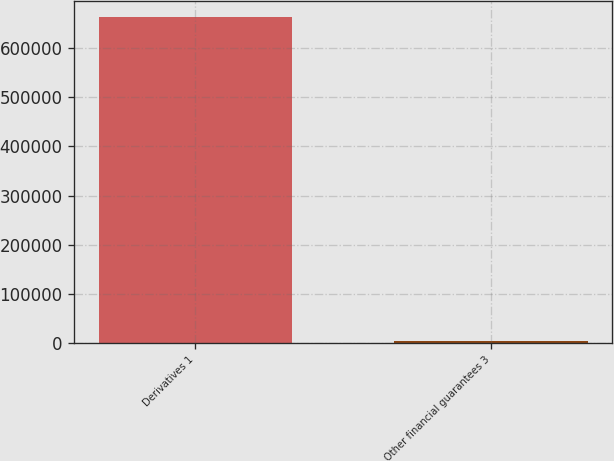Convert chart. <chart><loc_0><loc_0><loc_500><loc_500><bar_chart><fcel>Derivatives 1<fcel>Other financial guarantees 3<nl><fcel>663149<fcel>3479<nl></chart> 